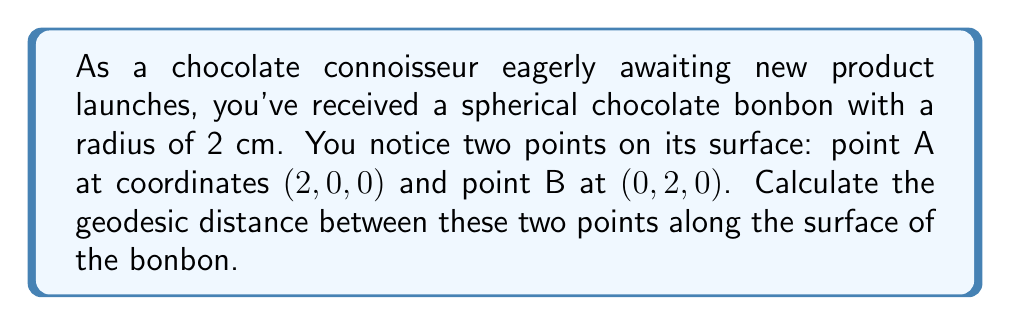Could you help me with this problem? To solve this problem, we'll follow these steps:

1) First, recall that the geodesic distance between two points on a sphere is given by the arc length of the great circle passing through these points.

2) The formula for the geodesic distance $d$ on a sphere of radius $r$ is:

   $$d = r \theta$$

   where $\theta$ is the central angle between the two points in radians.

3) To find $\theta$, we can use the dot product formula:

   $$\cos \theta = \frac{\vec{a} \cdot \vec{b}}{|\vec{a}||\vec{b}|}$$

   where $\vec{a}$ and $\vec{b}$ are vectors from the center of the sphere to points A and B respectively.

4) In our case:
   $\vec{a} = (2, 0, 0)$
   $\vec{b} = (0, 2, 0)$

5) Calculate the dot product:
   $$\vec{a} \cdot \vec{b} = 2 \cdot 0 + 0 \cdot 2 + 0 \cdot 0 = 0$$

6) Calculate the magnitudes:
   $$|\vec{a}| = |\vec{b}| = \sqrt{2^2 + 0^2 + 0^2} = 2$$

7) Substitute into the dot product formula:
   $$\cos \theta = \frac{0}{2 \cdot 2} = 0$$

8) Solve for $\theta$:
   $$\theta = \arccos(0) = \frac{\pi}{2}$$

9) Now we can calculate the geodesic distance:
   $$d = r \theta = 2 \cdot \frac{\pi}{2} = \pi$$

Therefore, the geodesic distance between the two points on the surface of the chocolate bonbon is $\pi$ cm.
Answer: $\pi$ cm 